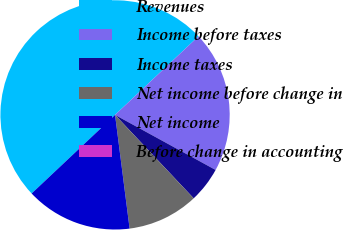Convert chart. <chart><loc_0><loc_0><loc_500><loc_500><pie_chart><fcel>Revenues<fcel>Income before taxes<fcel>Income taxes<fcel>Net income before change in<fcel>Net income<fcel>Before change in accounting<nl><fcel>50.0%<fcel>20.0%<fcel>5.0%<fcel>10.0%<fcel>15.0%<fcel>0.0%<nl></chart> 